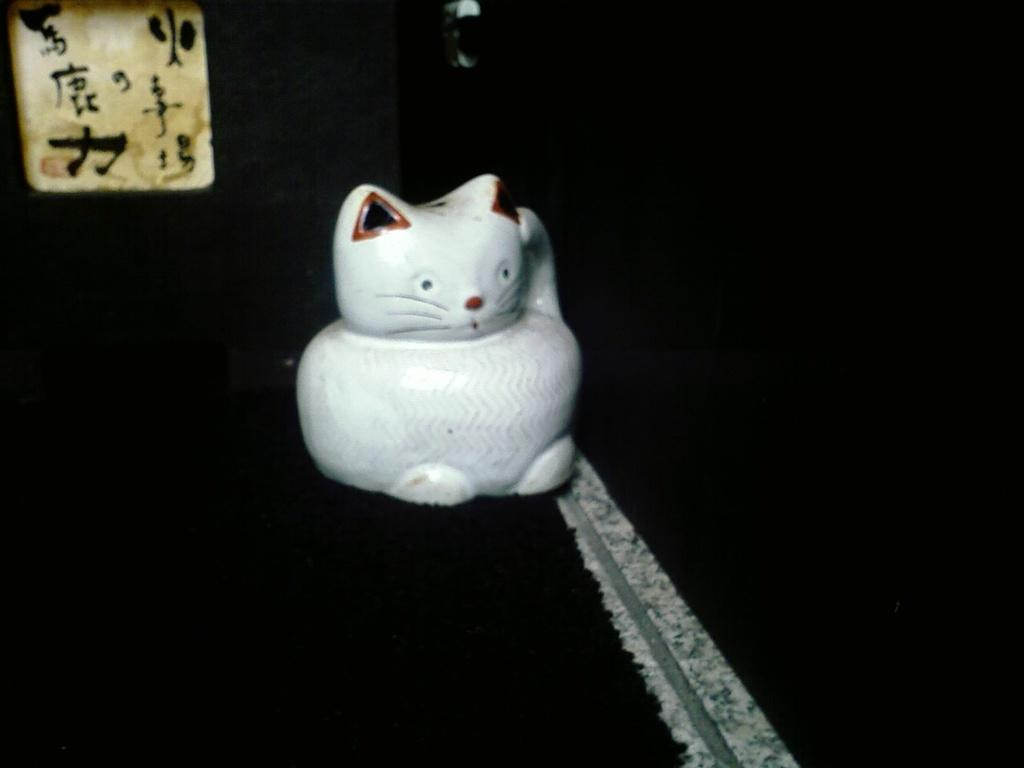What is the main subject of the image? There is a tot in the image. Can you describe the background of the image? The background of the image is dark. How many times does the tot say "good-bye" in the image? There is no indication in the image that the tot is saying anything, let alone "good-bye." 